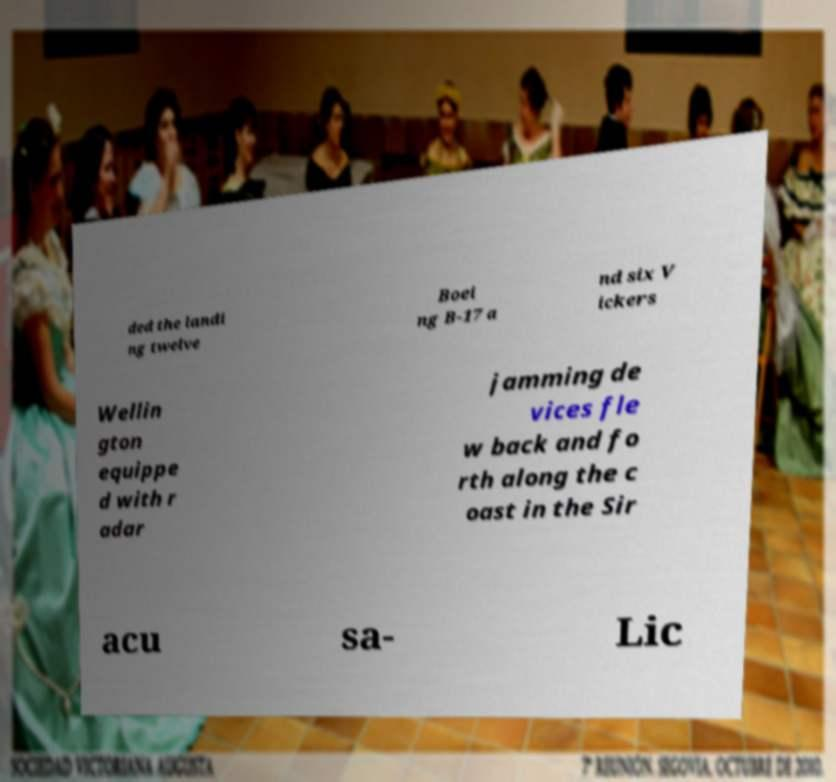Can you read and provide the text displayed in the image?This photo seems to have some interesting text. Can you extract and type it out for me? ded the landi ng twelve Boei ng B-17 a nd six V ickers Wellin gton equippe d with r adar jamming de vices fle w back and fo rth along the c oast in the Sir acu sa- Lic 